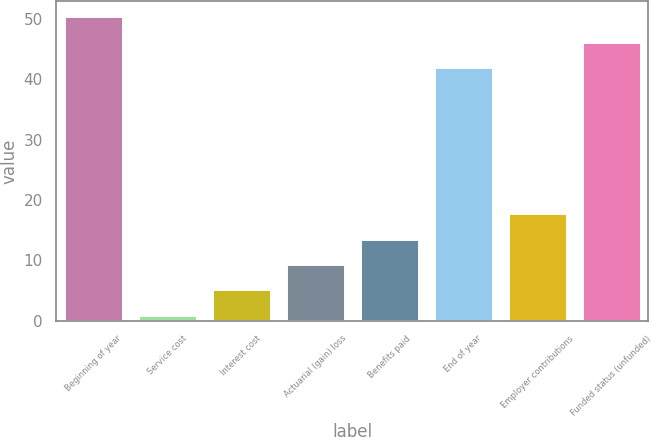Convert chart. <chart><loc_0><loc_0><loc_500><loc_500><bar_chart><fcel>Beginning of year<fcel>Service cost<fcel>Interest cost<fcel>Actuarial (gain) loss<fcel>Benefits paid<fcel>End of year<fcel>Employer contributions<fcel>Funded status (unfunded)<nl><fcel>50.4<fcel>1<fcel>5.2<fcel>9.4<fcel>13.6<fcel>42<fcel>17.8<fcel>46.2<nl></chart> 